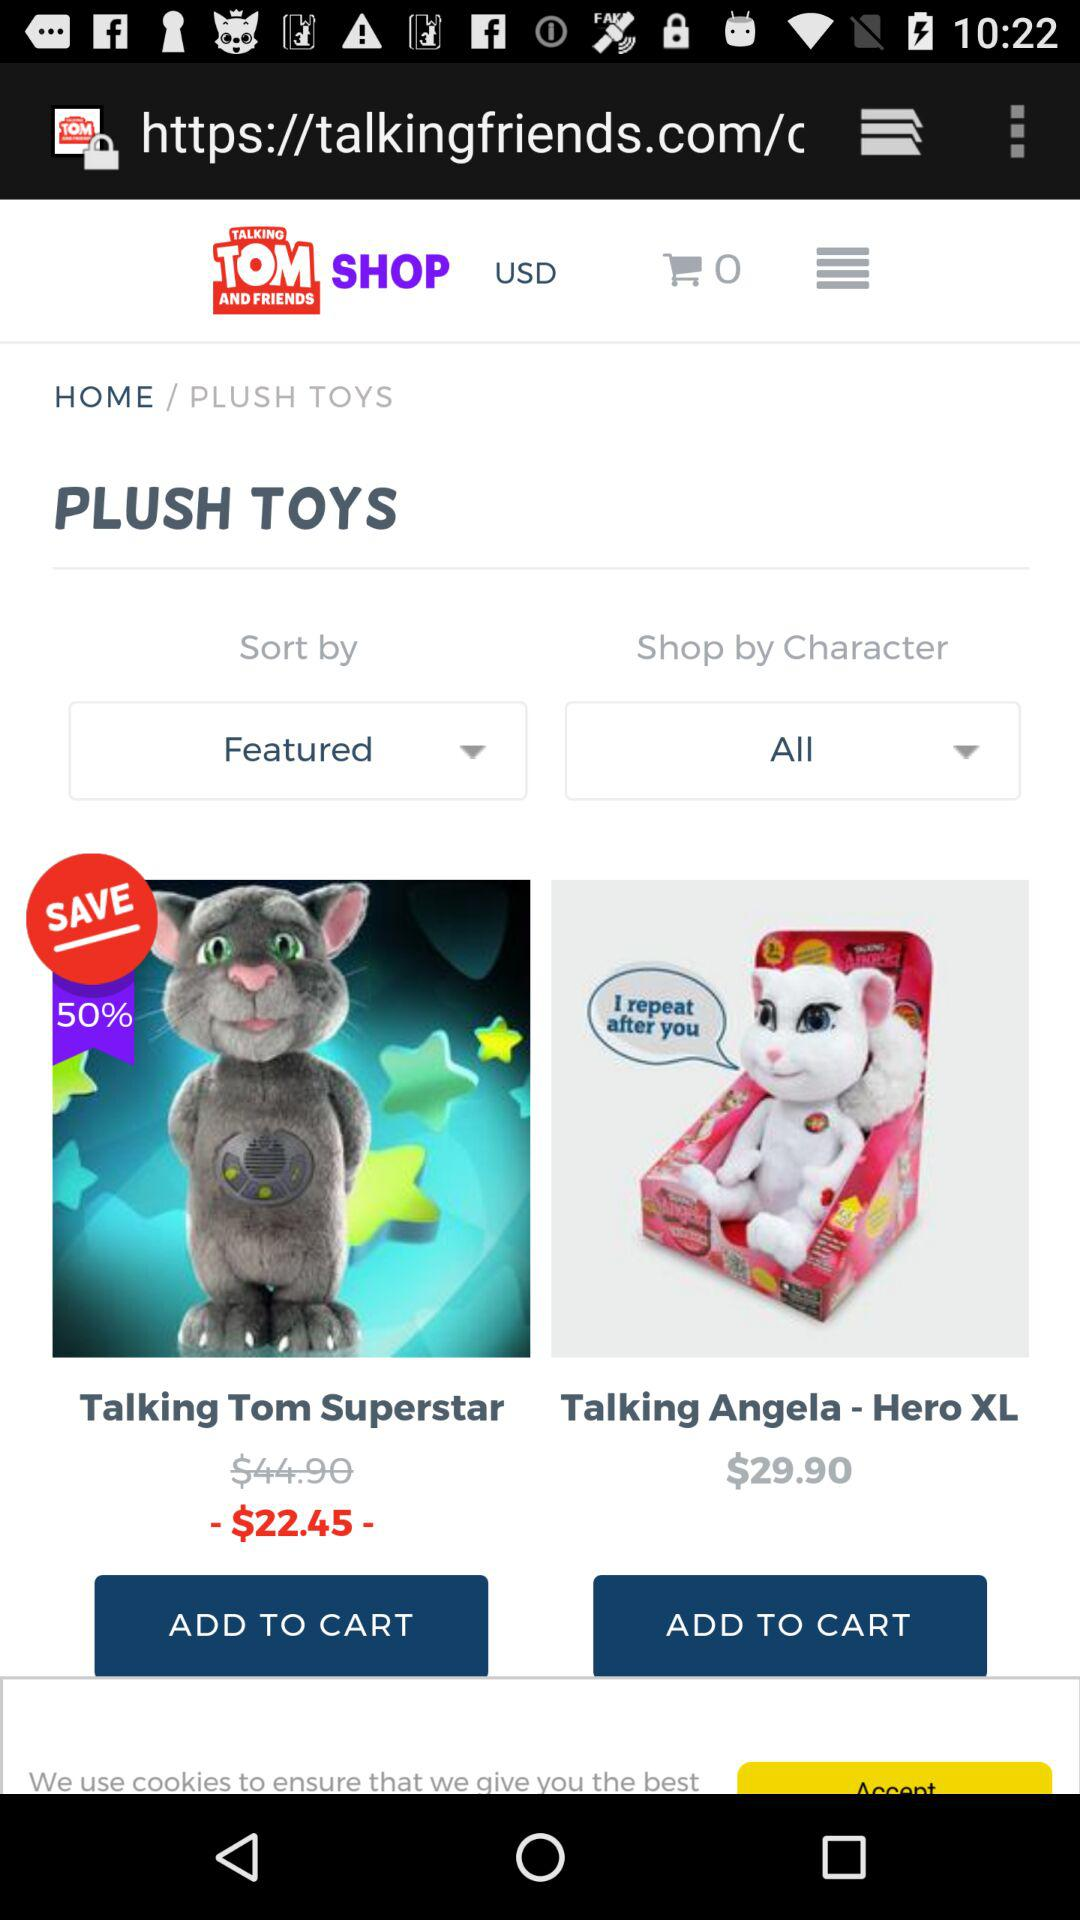What is the original cost of the Talking Tom Superstar? The original cost of the Talking Tom Superstar is $44.90. 